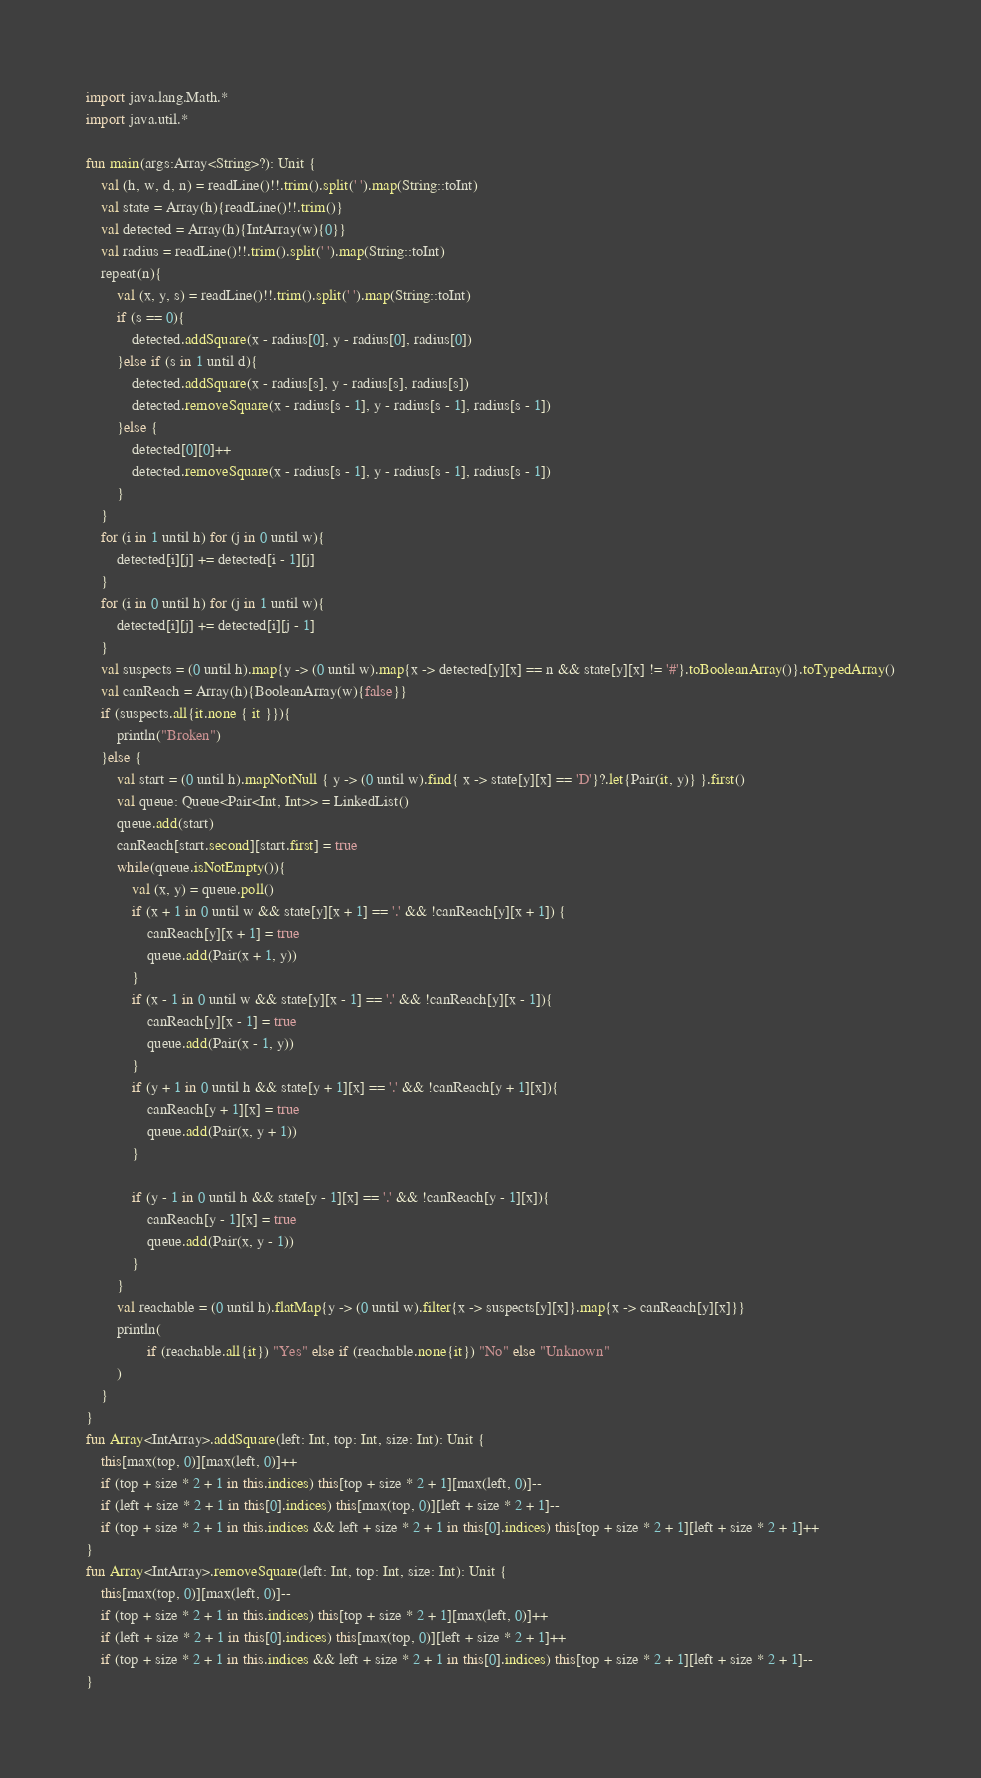Convert code to text. <code><loc_0><loc_0><loc_500><loc_500><_Kotlin_>import java.lang.Math.*
import java.util.*

fun main(args:Array<String>?): Unit {
    val (h, w, d, n) = readLine()!!.trim().split(' ').map(String::toInt)
    val state = Array(h){readLine()!!.trim()}
    val detected = Array(h){IntArray(w){0}}
    val radius = readLine()!!.trim().split(' ').map(String::toInt)
    repeat(n){
        val (x, y, s) = readLine()!!.trim().split(' ').map(String::toInt)
        if (s == 0){
            detected.addSquare(x - radius[0], y - radius[0], radius[0])
        }else if (s in 1 until d){
            detected.addSquare(x - radius[s], y - radius[s], radius[s])
            detected.removeSquare(x - radius[s - 1], y - radius[s - 1], radius[s - 1])
        }else {
            detected[0][0]++
            detected.removeSquare(x - radius[s - 1], y - radius[s - 1], radius[s - 1])
        }
    }
    for (i in 1 until h) for (j in 0 until w){
        detected[i][j] += detected[i - 1][j]
    }
    for (i in 0 until h) for (j in 1 until w){
        detected[i][j] += detected[i][j - 1]
    }
    val suspects = (0 until h).map{y -> (0 until w).map{x -> detected[y][x] == n && state[y][x] != '#'}.toBooleanArray()}.toTypedArray()
    val canReach = Array(h){BooleanArray(w){false}}
    if (suspects.all{it.none { it }}){
        println("Broken")
    }else {
        val start = (0 until h).mapNotNull { y -> (0 until w).find{ x -> state[y][x] == 'D'}?.let{Pair(it, y)} }.first()
        val queue: Queue<Pair<Int, Int>> = LinkedList()
        queue.add(start)
        canReach[start.second][start.first] = true
        while(queue.isNotEmpty()){
            val (x, y) = queue.poll()
            if (x + 1 in 0 until w && state[y][x + 1] == '.' && !canReach[y][x + 1]) {
                canReach[y][x + 1] = true
                queue.add(Pair(x + 1, y))
            }
            if (x - 1 in 0 until w && state[y][x - 1] == '.' && !canReach[y][x - 1]){
                canReach[y][x - 1] = true
                queue.add(Pair(x - 1, y))
            }
            if (y + 1 in 0 until h && state[y + 1][x] == '.' && !canReach[y + 1][x]){
                canReach[y + 1][x] = true
                queue.add(Pair(x, y + 1))
            }

            if (y - 1 in 0 until h && state[y - 1][x] == '.' && !canReach[y - 1][x]){
                canReach[y - 1][x] = true
                queue.add(Pair(x, y - 1))
            }
        }
        val reachable = (0 until h).flatMap{y -> (0 until w).filter{x -> suspects[y][x]}.map{x -> canReach[y][x]}}
        println(
                if (reachable.all{it}) "Yes" else if (reachable.none{it}) "No" else "Unknown"
        )
    }
}
fun Array<IntArray>.addSquare(left: Int, top: Int, size: Int): Unit {
    this[max(top, 0)][max(left, 0)]++
    if (top + size * 2 + 1 in this.indices) this[top + size * 2 + 1][max(left, 0)]--
    if (left + size * 2 + 1 in this[0].indices) this[max(top, 0)][left + size * 2 + 1]--
    if (top + size * 2 + 1 in this.indices && left + size * 2 + 1 in this[0].indices) this[top + size * 2 + 1][left + size * 2 + 1]++
}
fun Array<IntArray>.removeSquare(left: Int, top: Int, size: Int): Unit {
    this[max(top, 0)][max(left, 0)]--
    if (top + size * 2 + 1 in this.indices) this[top + size * 2 + 1][max(left, 0)]++
    if (left + size * 2 + 1 in this[0].indices) this[max(top, 0)][left + size * 2 + 1]++
    if (top + size * 2 + 1 in this.indices && left + size * 2 + 1 in this[0].indices) this[top + size * 2 + 1][left + size * 2 + 1]--
}
</code> 